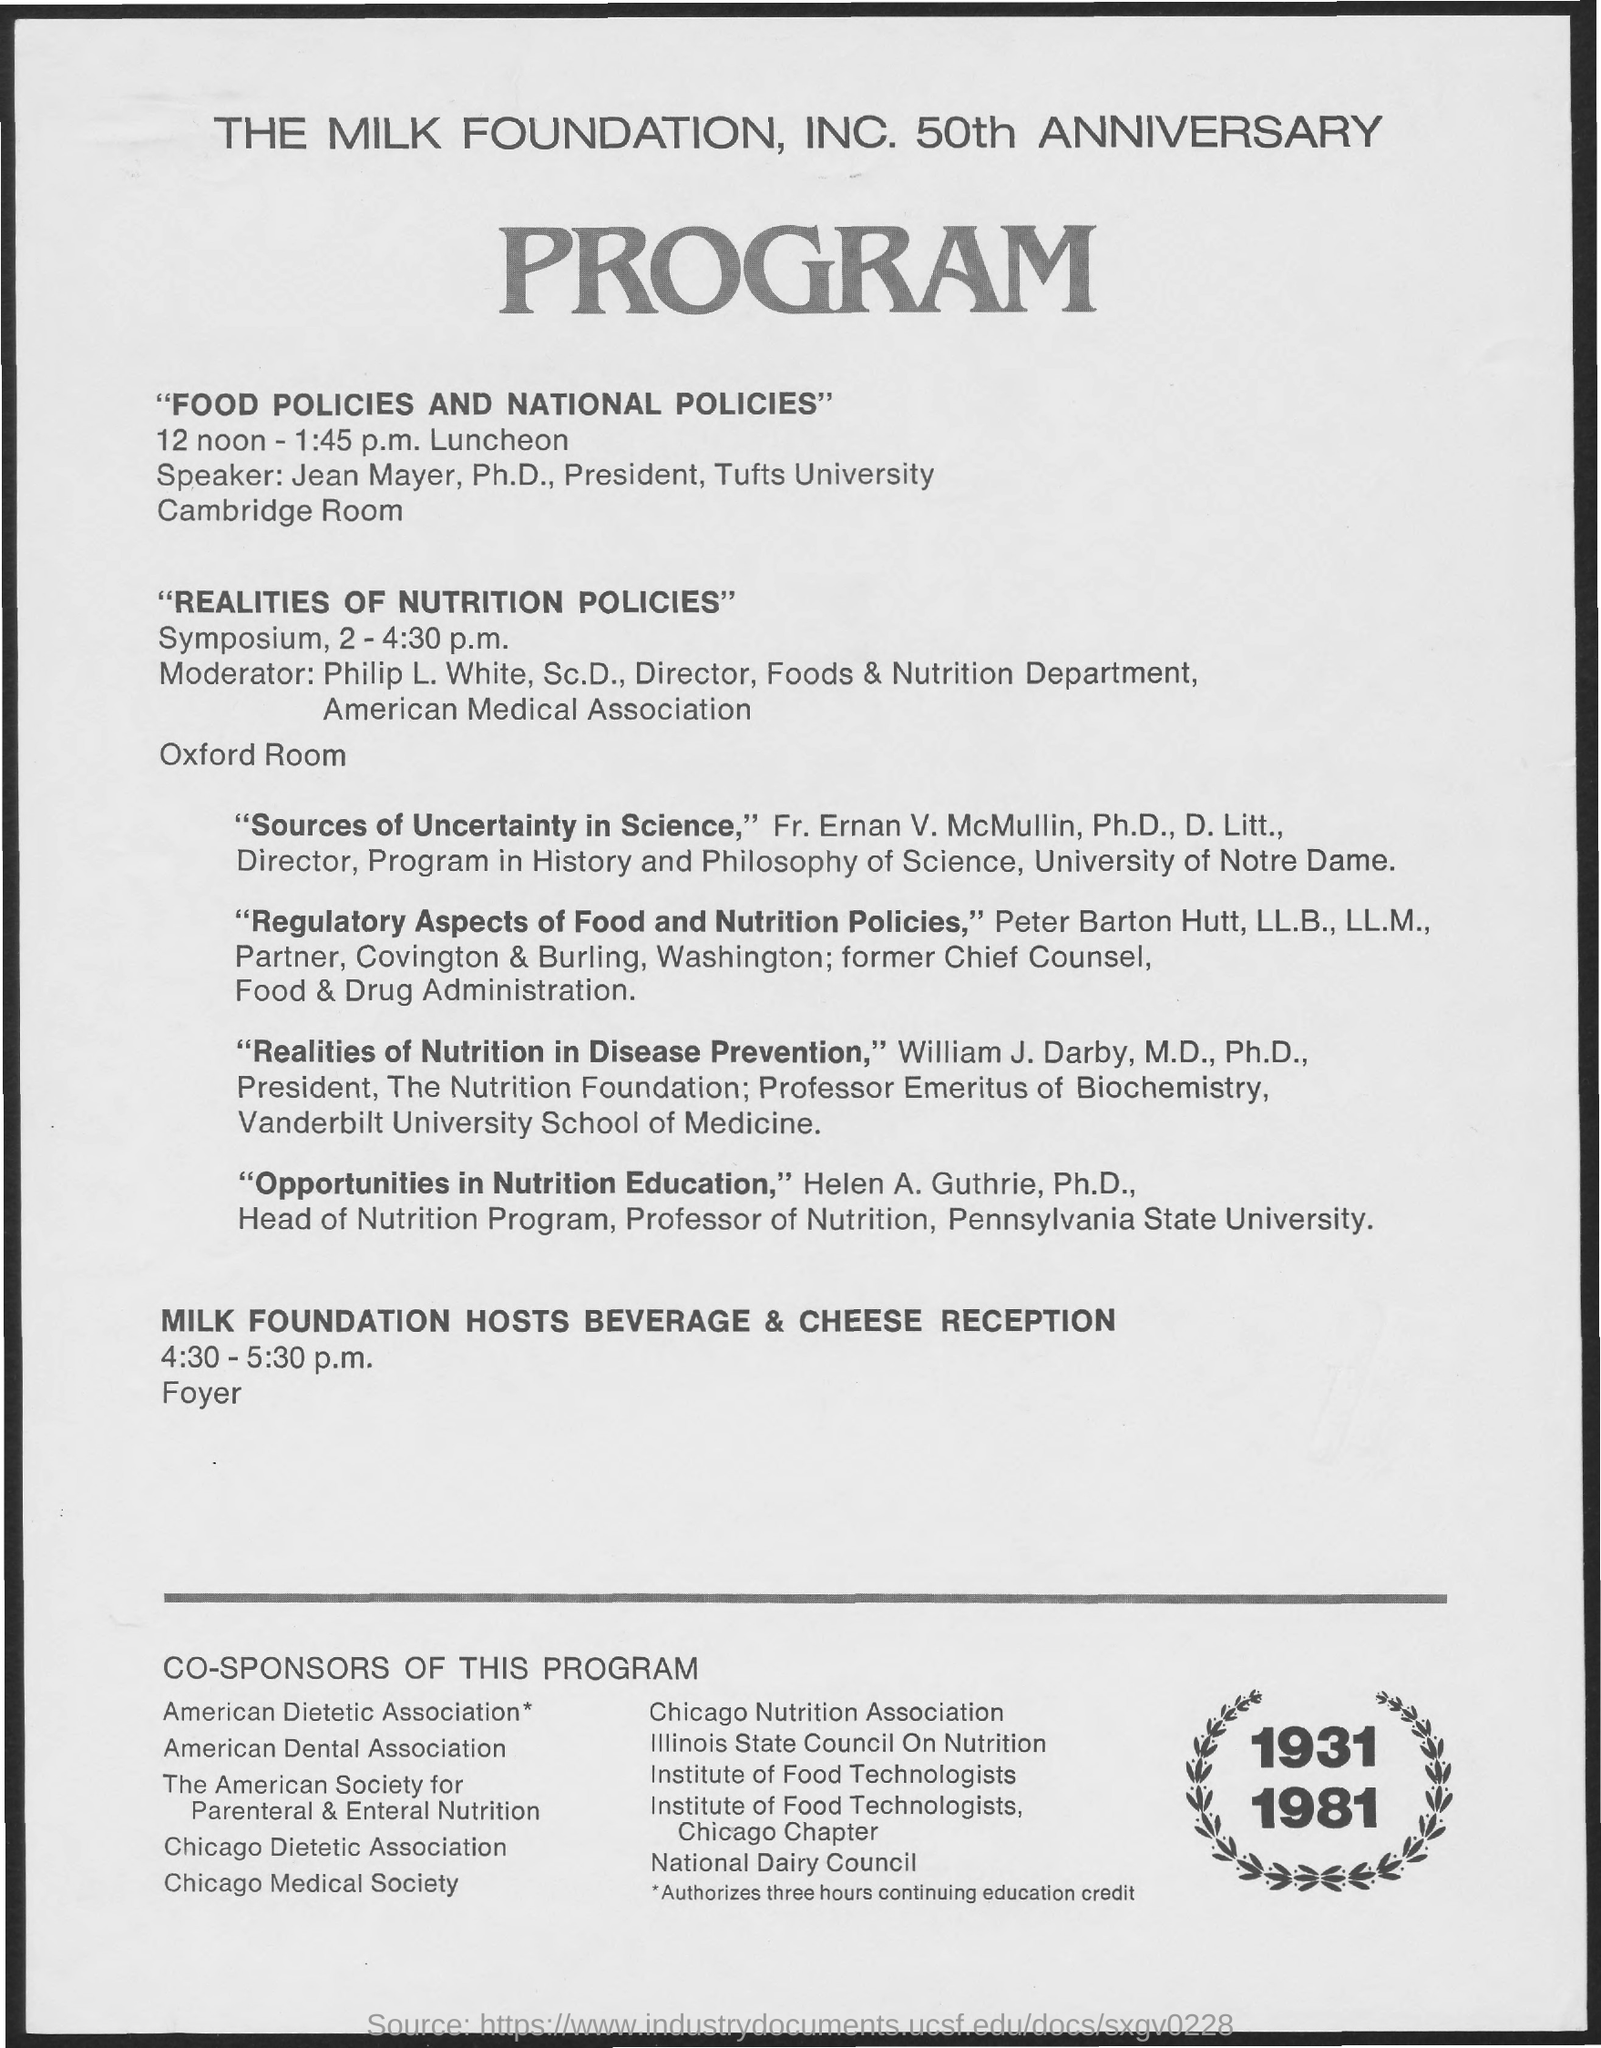Who is the speaker of "food policies and national policies"?
Keep it short and to the point. Mayer. What will be the timings for Milk Foundation Hosts Beverage & Cheese Reception?
Your answer should be compact. 4:30 - 5:30 p.m. 